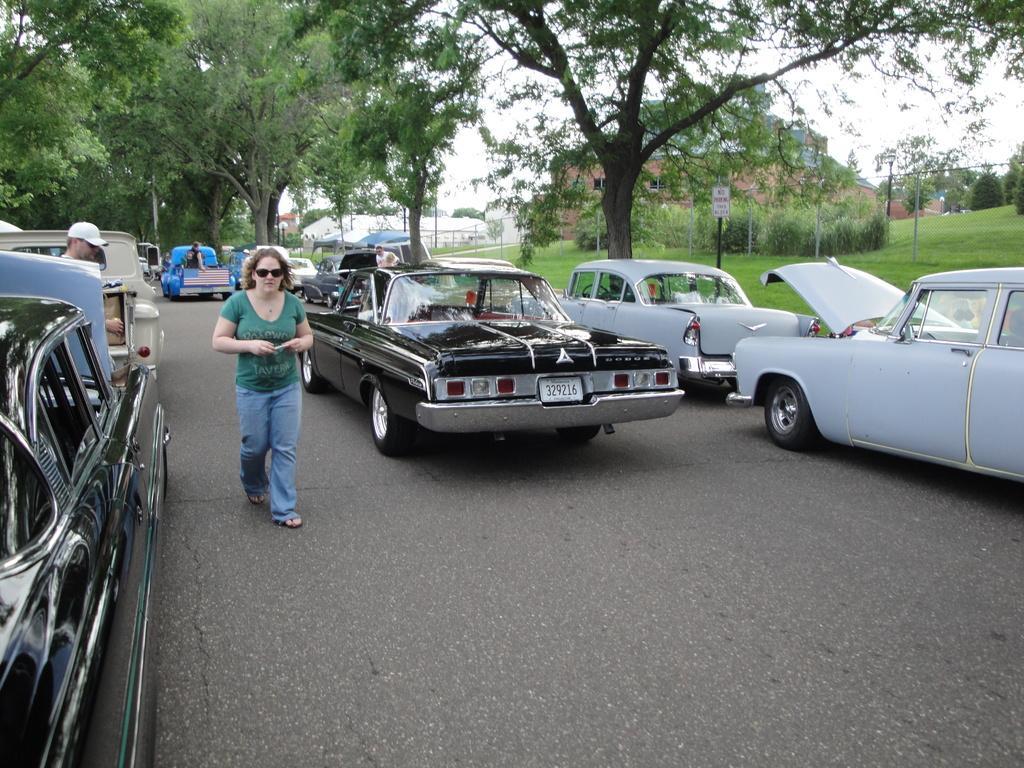In one or two sentences, can you explain what this image depicts? In this image I can see the vehicles on the road. I can also see some people. In the background, I can see the trees, buildings and the sky. 